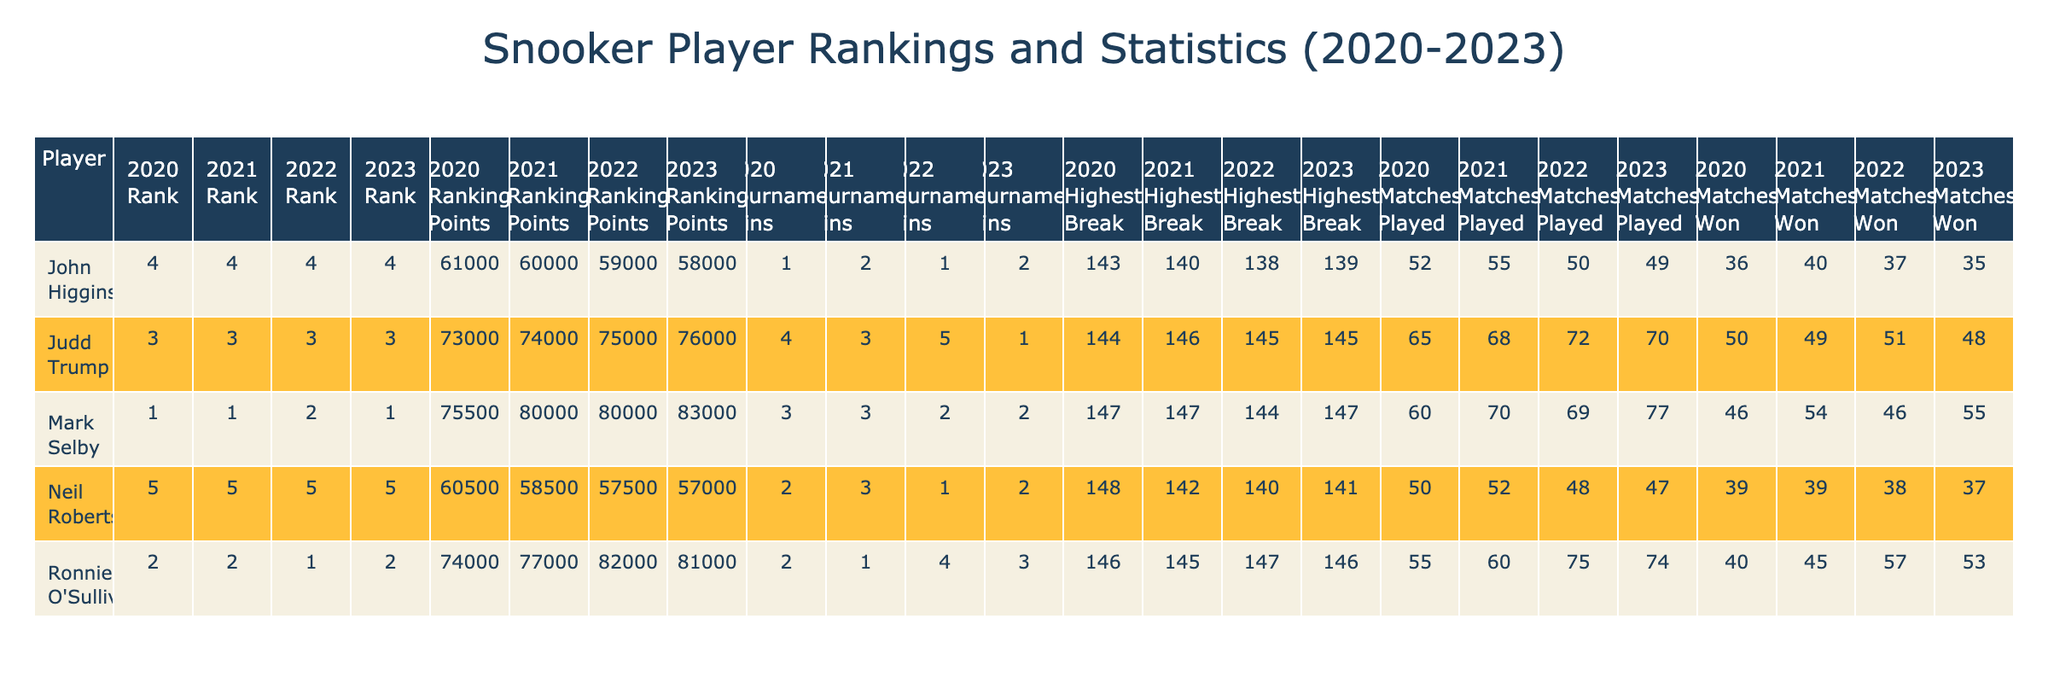What was the highest break achieved by Ronnie O'Sullivan in 2022? In 2022, Ronnie O'Sullivan's highest break is listed in the table as 147.
Answer: 147 Which player had the most tournament wins in 2021? By reviewing the tournament wins column for 2021, Judd Trump had the most with 3 wins.
Answer: Judd Trump What is the difference in ranking points for Mark Selby from 2020 to 2023? In 2020, Mark Selby had 75500 ranking points, and in 2023 he had 83000. The difference is 83000 - 75500 = 7500 points.
Answer: 7500 Did John Higgins win more matches in 2021 or 2022? In 2021, John Higgins won 40 matches, while in 2022 he won 37 matches. Therefore, he won more matches in 2021.
Answer: Yes Which player had the highest number of matches played in 2020? Reviewing the matches played column for 2020, Judd Trump played 65 matches, which is the highest compared to other players that year.
Answer: Judd Trump What was the average ranking points of Neil Robertson from 2020 to 2023? Neil Robertson's ranking points over the four years are 60500 (2020), 58500 (2021), 57500 (2022), and 57000 (2023). The average is (60500 + 58500 + 57500 + 57000) / 4 = 58250.
Answer: 58250 Compare the highest breaks of all players in 2021. Who had the highest? In 2021, Mark Selby had a highest break of 147, Ronnie O'Sullivan had 145, Judd Trump had 146, John Higgins had 140, and Neil Robertson had 142. Thus, Mark Selby had the highest break in that year.
Answer: Mark Selby Which player maintained the same rank (1st) from 2020 to 2023? By checking the rank column for each year, Mark Selby is ranked 1st in all four years from 2020 to 2023.
Answer: Mark Selby In terms of tournament wins, which player improved the most from 2020 to 2023? By comparing the tournament wins from both years, Judd Trump had 4 wins in 2020 and 1 win in 2023, showing a decrease; Mark Selby had 3 wins in 2020 and 2 in 2023, Neil Robertson had 2 wins in 2020 and 1 in 2022. Therefore, nobody improved in tournament wins.
Answer: No player improved Calculate the total number of matches played by Ronnie O'Sullivan across all years. Adding the matches played by Ronnie O'Sullivan: 55 (2020) + 60 (2021) + 75 (2022) + 74 (2023) = 264 matches in total.
Answer: 264 